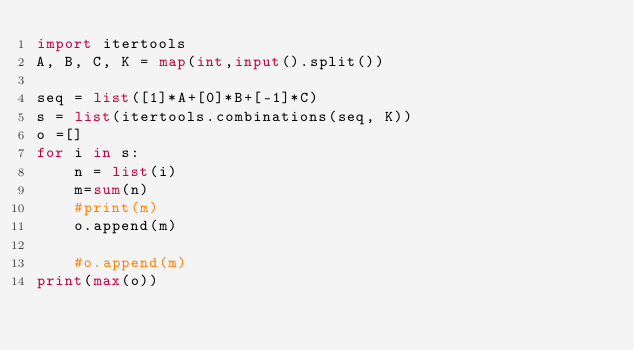Convert code to text. <code><loc_0><loc_0><loc_500><loc_500><_Python_>import itertools
A, B, C, K = map(int,input().split())

seq = list([1]*A+[0]*B+[-1]*C)
s = list(itertools.combinations(seq, K))
o =[]
for i in s:
    n = list(i)
    m=sum(n)
    #print(m)
    o.append(m)

    #o.append(m)
print(max(o))</code> 